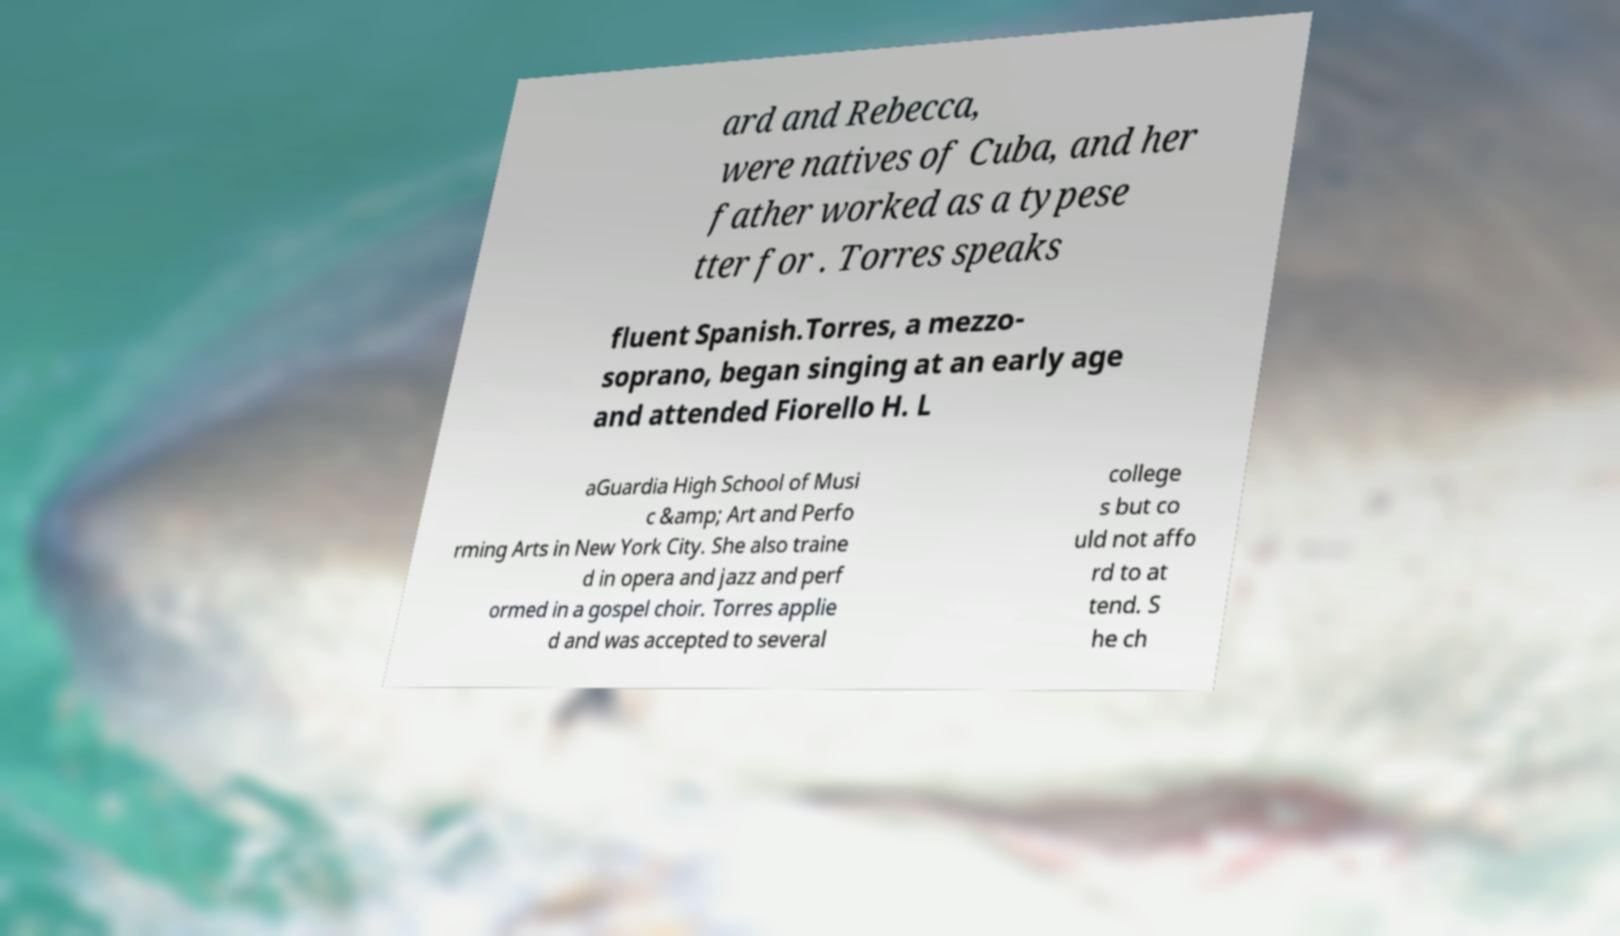Can you read and provide the text displayed in the image?This photo seems to have some interesting text. Can you extract and type it out for me? ard and Rebecca, were natives of Cuba, and her father worked as a typese tter for . Torres speaks fluent Spanish.Torres, a mezzo- soprano, began singing at an early age and attended Fiorello H. L aGuardia High School of Musi c &amp; Art and Perfo rming Arts in New York City. She also traine d in opera and jazz and perf ormed in a gospel choir. Torres applie d and was accepted to several college s but co uld not affo rd to at tend. S he ch 